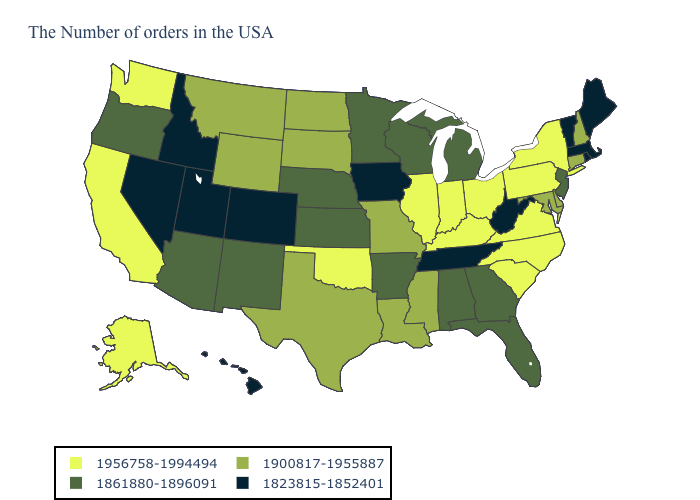What is the value of Kentucky?
Write a very short answer. 1956758-1994494. What is the highest value in states that border Vermont?
Concise answer only. 1956758-1994494. Which states hav the highest value in the South?
Quick response, please. Virginia, North Carolina, South Carolina, Kentucky, Oklahoma. Which states have the lowest value in the USA?
Write a very short answer. Maine, Massachusetts, Rhode Island, Vermont, West Virginia, Tennessee, Iowa, Colorado, Utah, Idaho, Nevada, Hawaii. Name the states that have a value in the range 1900817-1955887?
Keep it brief. New Hampshire, Connecticut, Delaware, Maryland, Mississippi, Louisiana, Missouri, Texas, South Dakota, North Dakota, Wyoming, Montana. Among the states that border Connecticut , does Massachusetts have the lowest value?
Answer briefly. Yes. What is the value of New Mexico?
Answer briefly. 1861880-1896091. Name the states that have a value in the range 1956758-1994494?
Answer briefly. New York, Pennsylvania, Virginia, North Carolina, South Carolina, Ohio, Kentucky, Indiana, Illinois, Oklahoma, California, Washington, Alaska. Which states have the lowest value in the USA?
Answer briefly. Maine, Massachusetts, Rhode Island, Vermont, West Virginia, Tennessee, Iowa, Colorado, Utah, Idaho, Nevada, Hawaii. Does New York have the lowest value in the Northeast?
Concise answer only. No. Which states hav the highest value in the South?
Be succinct. Virginia, North Carolina, South Carolina, Kentucky, Oklahoma. Name the states that have a value in the range 1823815-1852401?
Quick response, please. Maine, Massachusetts, Rhode Island, Vermont, West Virginia, Tennessee, Iowa, Colorado, Utah, Idaho, Nevada, Hawaii. Among the states that border South Dakota , which have the lowest value?
Concise answer only. Iowa. What is the value of Delaware?
Be succinct. 1900817-1955887. 